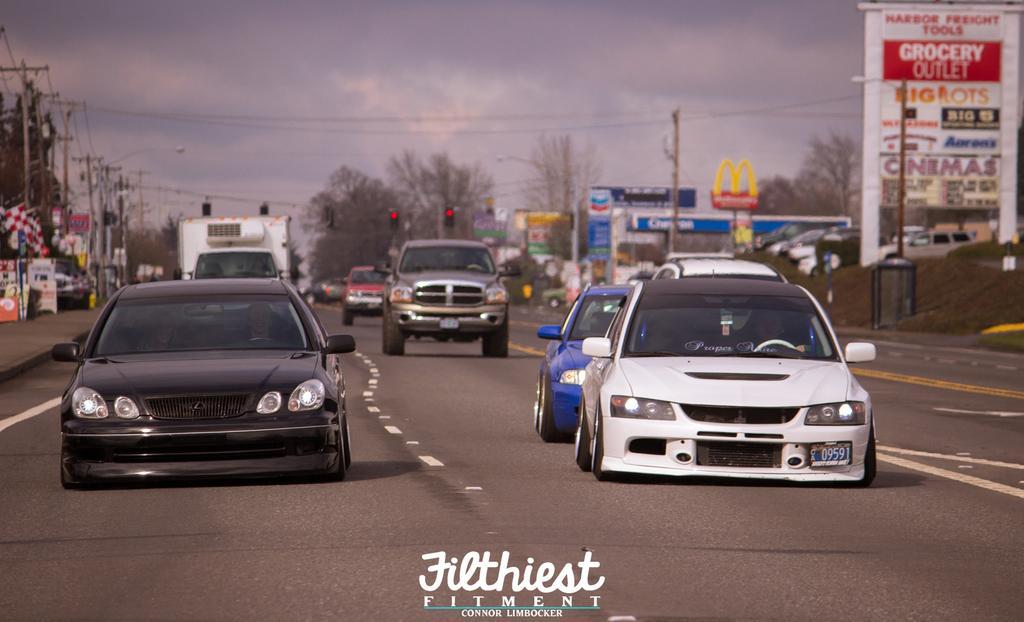<image>
Present a compact description of the photo's key features. Several cars drive down a road; in the background is a sign advertising a grocery outlet. 